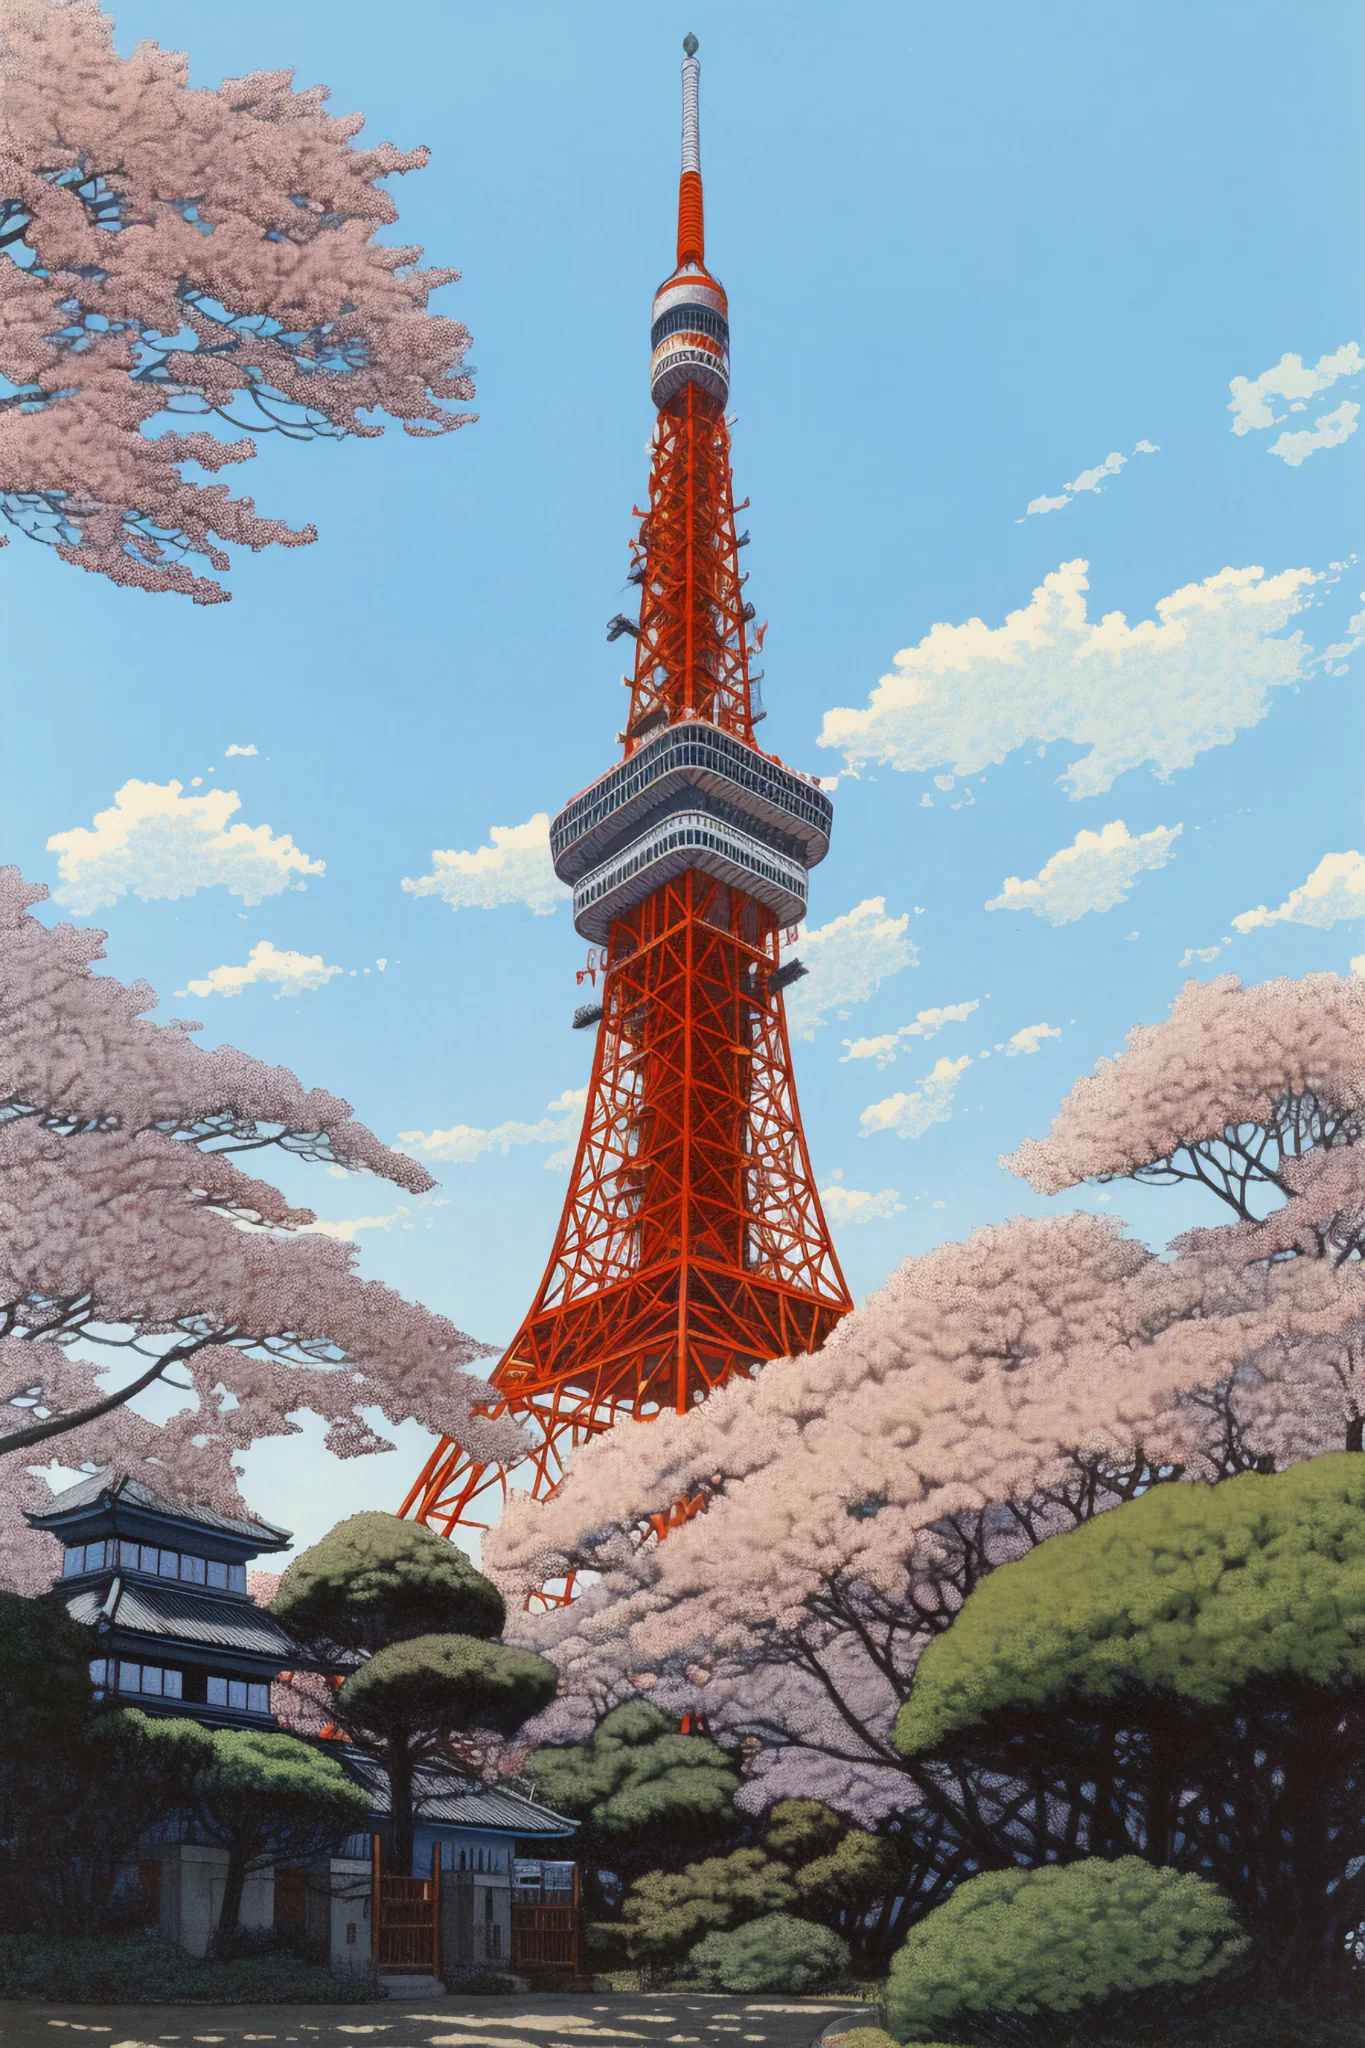Can we delve into the architectural features of the Tokyo Tower? Absolutely! Tokyo Tower is a communications and observation tower in the Shiba-koen district of Minato, Tokyo. Standing at 333 meters, it's the second-tallest structure in Japan. Its design was inspired by the Eiffel Tower and it serves as a television and radio broadcast antenna. The tower has two observation decks for the public: the Main Deck, located at 150 meters, and the Top Deck at 250 meters, offering panoramic views of Tokyo. The vibrant orange and white colors were chosen to comply with air safety regulations. 